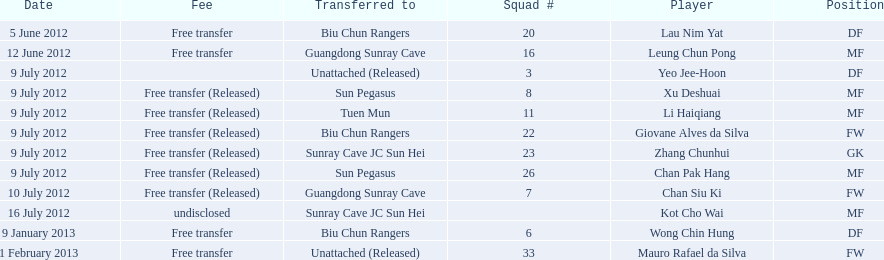Which players are listed? Lau Nim Yat, Leung Chun Pong, Yeo Jee-Hoon, Xu Deshuai, Li Haiqiang, Giovane Alves da Silva, Zhang Chunhui, Chan Pak Hang, Chan Siu Ki, Kot Cho Wai, Wong Chin Hung, Mauro Rafael da Silva. Which dates were players transferred to the biu chun rangers? 5 June 2012, 9 July 2012, 9 January 2013. Of those which is the date for wong chin hung? 9 January 2013. 